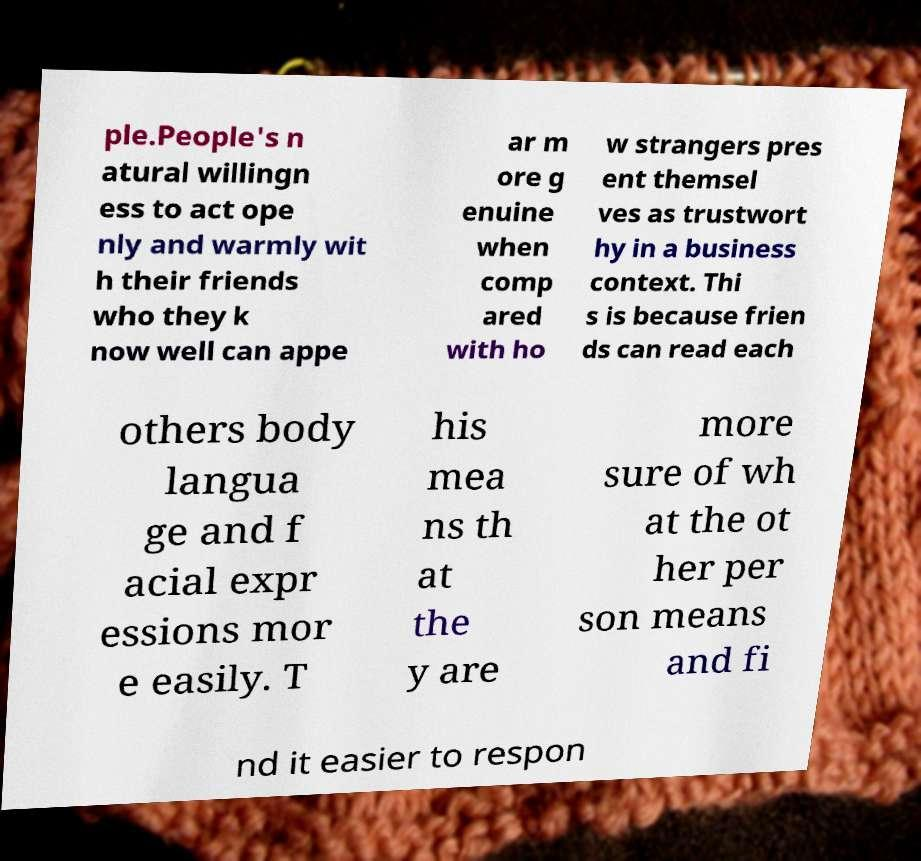What messages or text are displayed in this image? I need them in a readable, typed format. ple.People's n atural willingn ess to act ope nly and warmly wit h their friends who they k now well can appe ar m ore g enuine when comp ared with ho w strangers pres ent themsel ves as trustwort hy in a business context. Thi s is because frien ds can read each others body langua ge and f acial expr essions mor e easily. T his mea ns th at the y are more sure of wh at the ot her per son means and fi nd it easier to respon 